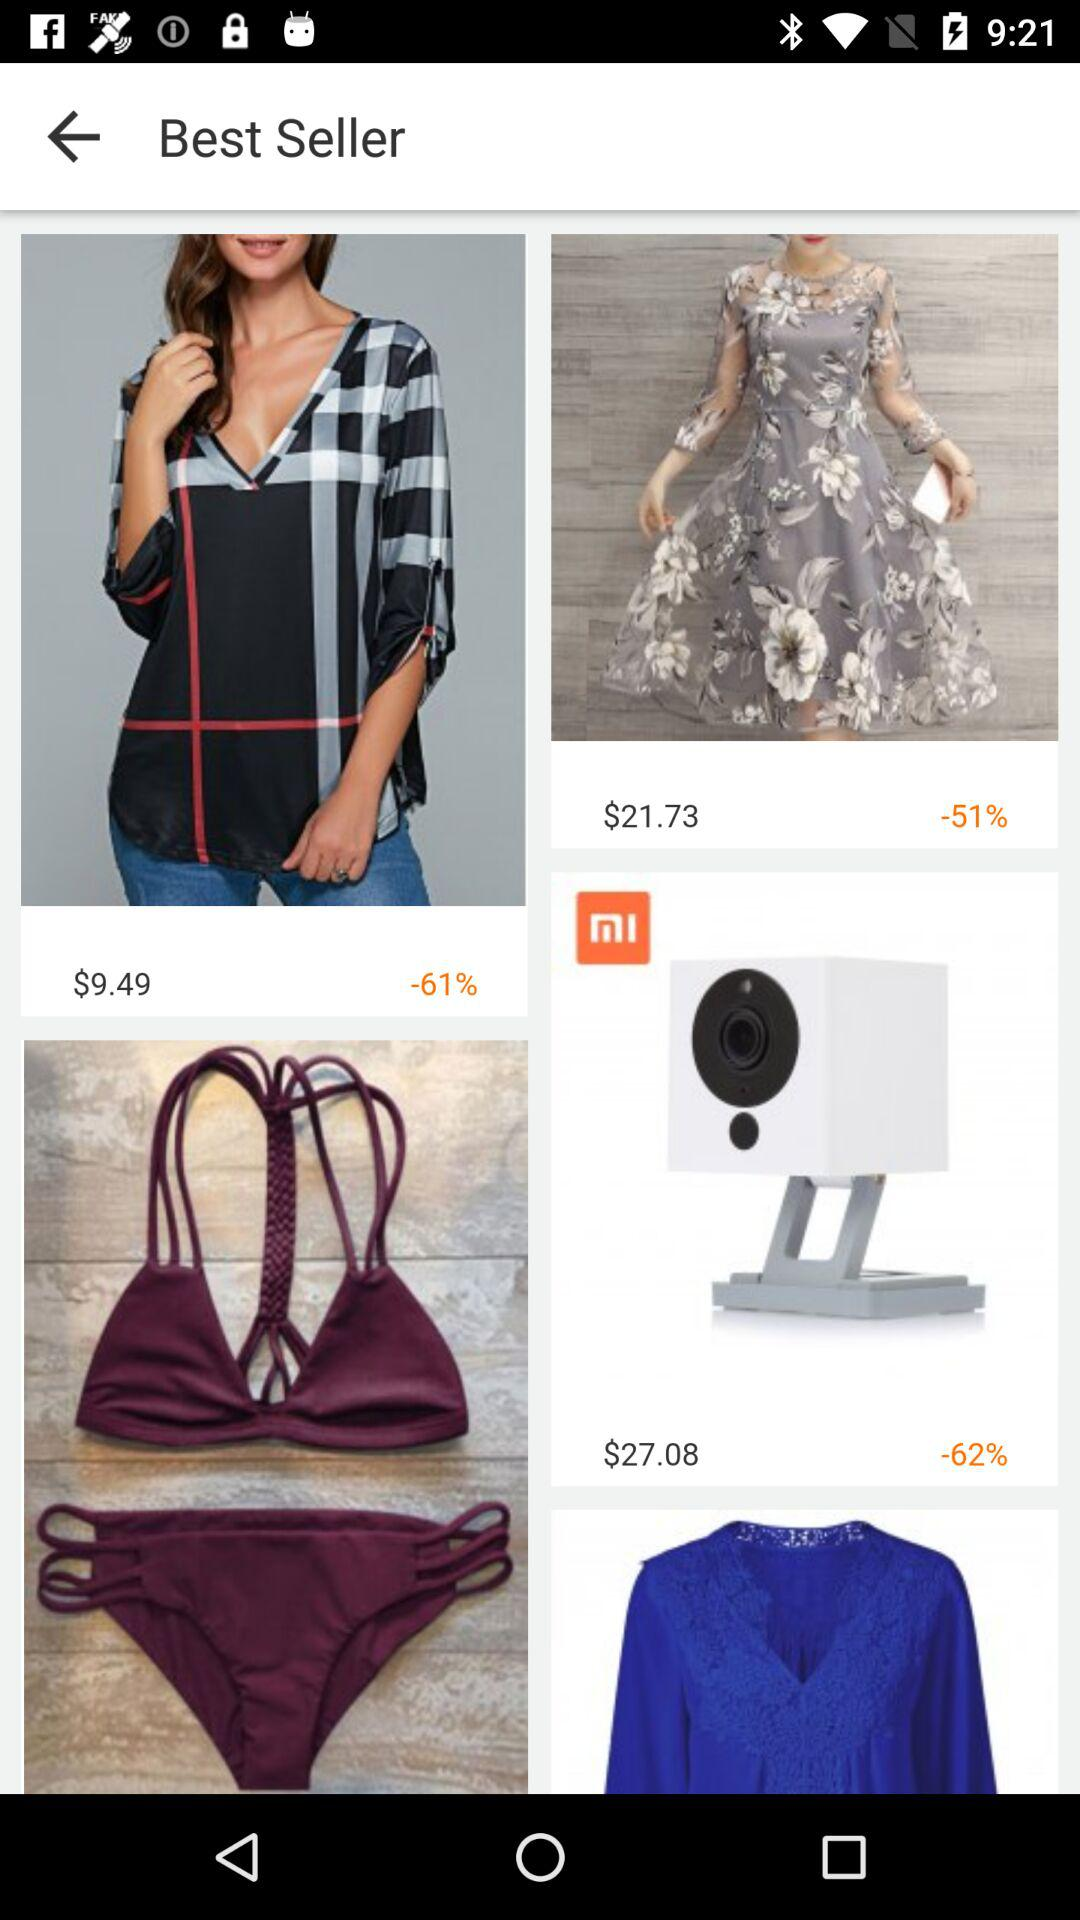What is the price of a dress?
When the provided information is insufficient, respond with <no answer>. <no answer> 